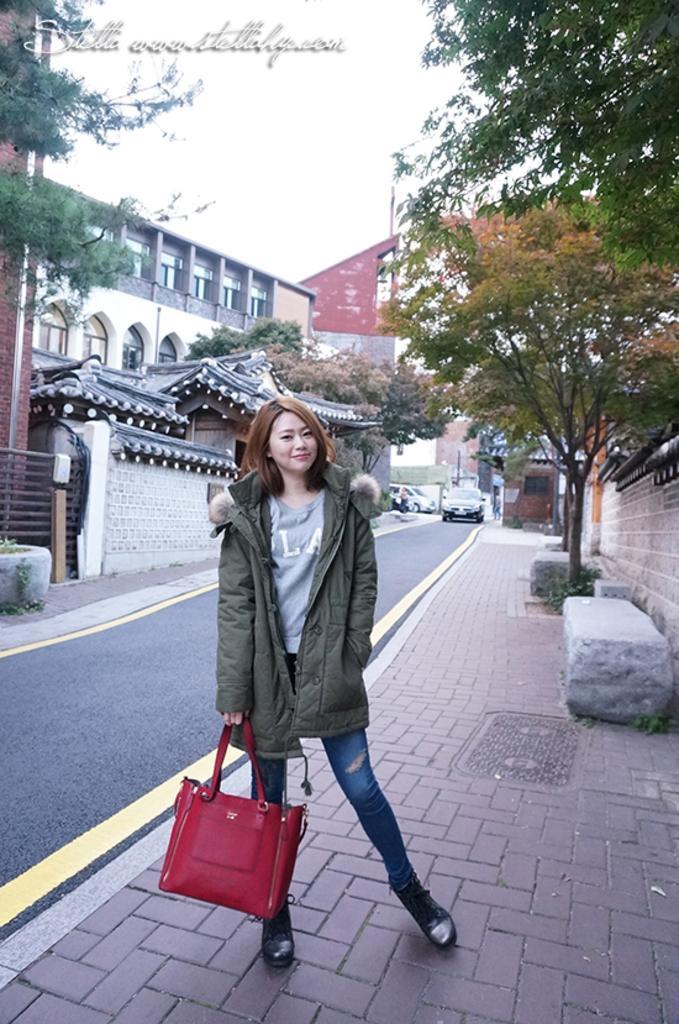How would you summarize this image in a sentence or two? This picture is taken on the road side, In the middle there is a woman she is standing and holding a bag which is in red color, In the left side there is a road in black color, In the right side there is a tree which is in green color and there is a stone in white color. 